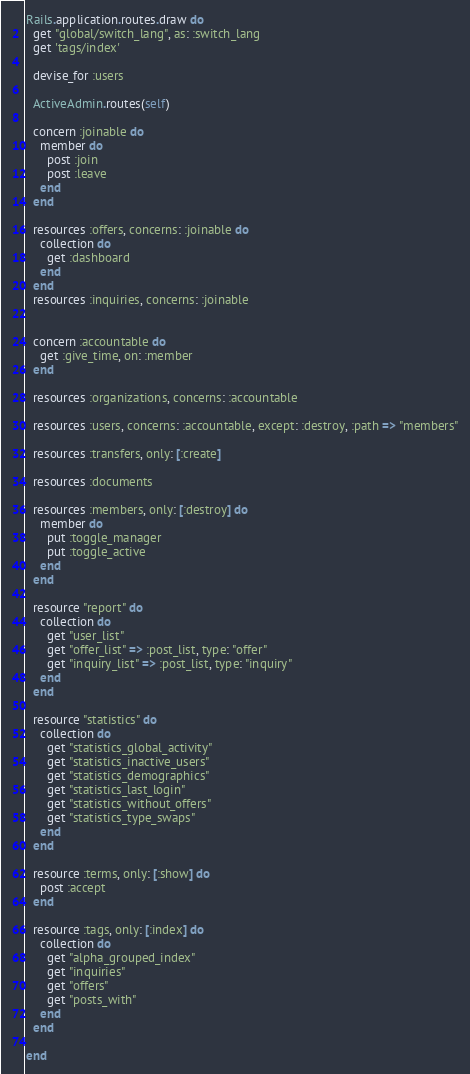Convert code to text. <code><loc_0><loc_0><loc_500><loc_500><_Ruby_>Rails.application.routes.draw do
  get "global/switch_lang", as: :switch_lang
  get 'tags/index'

  devise_for :users

  ActiveAdmin.routes(self)

  concern :joinable do
    member do
      post :join
      post :leave
    end
  end

  resources :offers, concerns: :joinable do
    collection do
      get :dashboard
    end
  end
  resources :inquiries, concerns: :joinable


  concern :accountable do
    get :give_time, on: :member
  end

  resources :organizations, concerns: :accountable

  resources :users, concerns: :accountable, except: :destroy, :path => "members"

  resources :transfers, only: [:create]

  resources :documents

  resources :members, only: [:destroy] do
    member do
      put :toggle_manager
      put :toggle_active
    end
  end

  resource "report" do
    collection do
      get "user_list"
      get "offer_list" => :post_list, type: "offer"
      get "inquiry_list" => :post_list, type: "inquiry"
    end
  end

  resource "statistics" do
    collection do
      get "statistics_global_activity"
      get "statistics_inactive_users"
      get "statistics_demographics"
      get "statistics_last_login"
      get "statistics_without_offers"
      get "statistics_type_swaps"
    end
  end

  resource :terms, only: [:show] do
    post :accept
  end

  resource :tags, only: [:index] do
    collection do
      get "alpha_grouped_index"
      get "inquiries"
      get "offers"
      get "posts_with"
    end
  end

end
</code> 